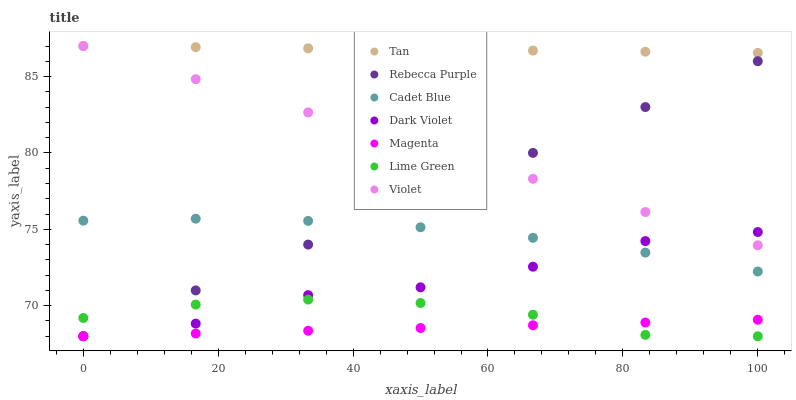Does Magenta have the minimum area under the curve?
Answer yes or no. Yes. Does Tan have the maximum area under the curve?
Answer yes or no. Yes. Does Dark Violet have the minimum area under the curve?
Answer yes or no. No. Does Dark Violet have the maximum area under the curve?
Answer yes or no. No. Is Violet the smoothest?
Answer yes or no. Yes. Is Dark Violet the roughest?
Answer yes or no. Yes. Is Rebecca Purple the smoothest?
Answer yes or no. No. Is Rebecca Purple the roughest?
Answer yes or no. No. Does Dark Violet have the lowest value?
Answer yes or no. Yes. Does Violet have the lowest value?
Answer yes or no. No. Does Tan have the highest value?
Answer yes or no. Yes. Does Dark Violet have the highest value?
Answer yes or no. No. Is Lime Green less than Cadet Blue?
Answer yes or no. Yes. Is Tan greater than Dark Violet?
Answer yes or no. Yes. Does Lime Green intersect Magenta?
Answer yes or no. Yes. Is Lime Green less than Magenta?
Answer yes or no. No. Is Lime Green greater than Magenta?
Answer yes or no. No. Does Lime Green intersect Cadet Blue?
Answer yes or no. No. 